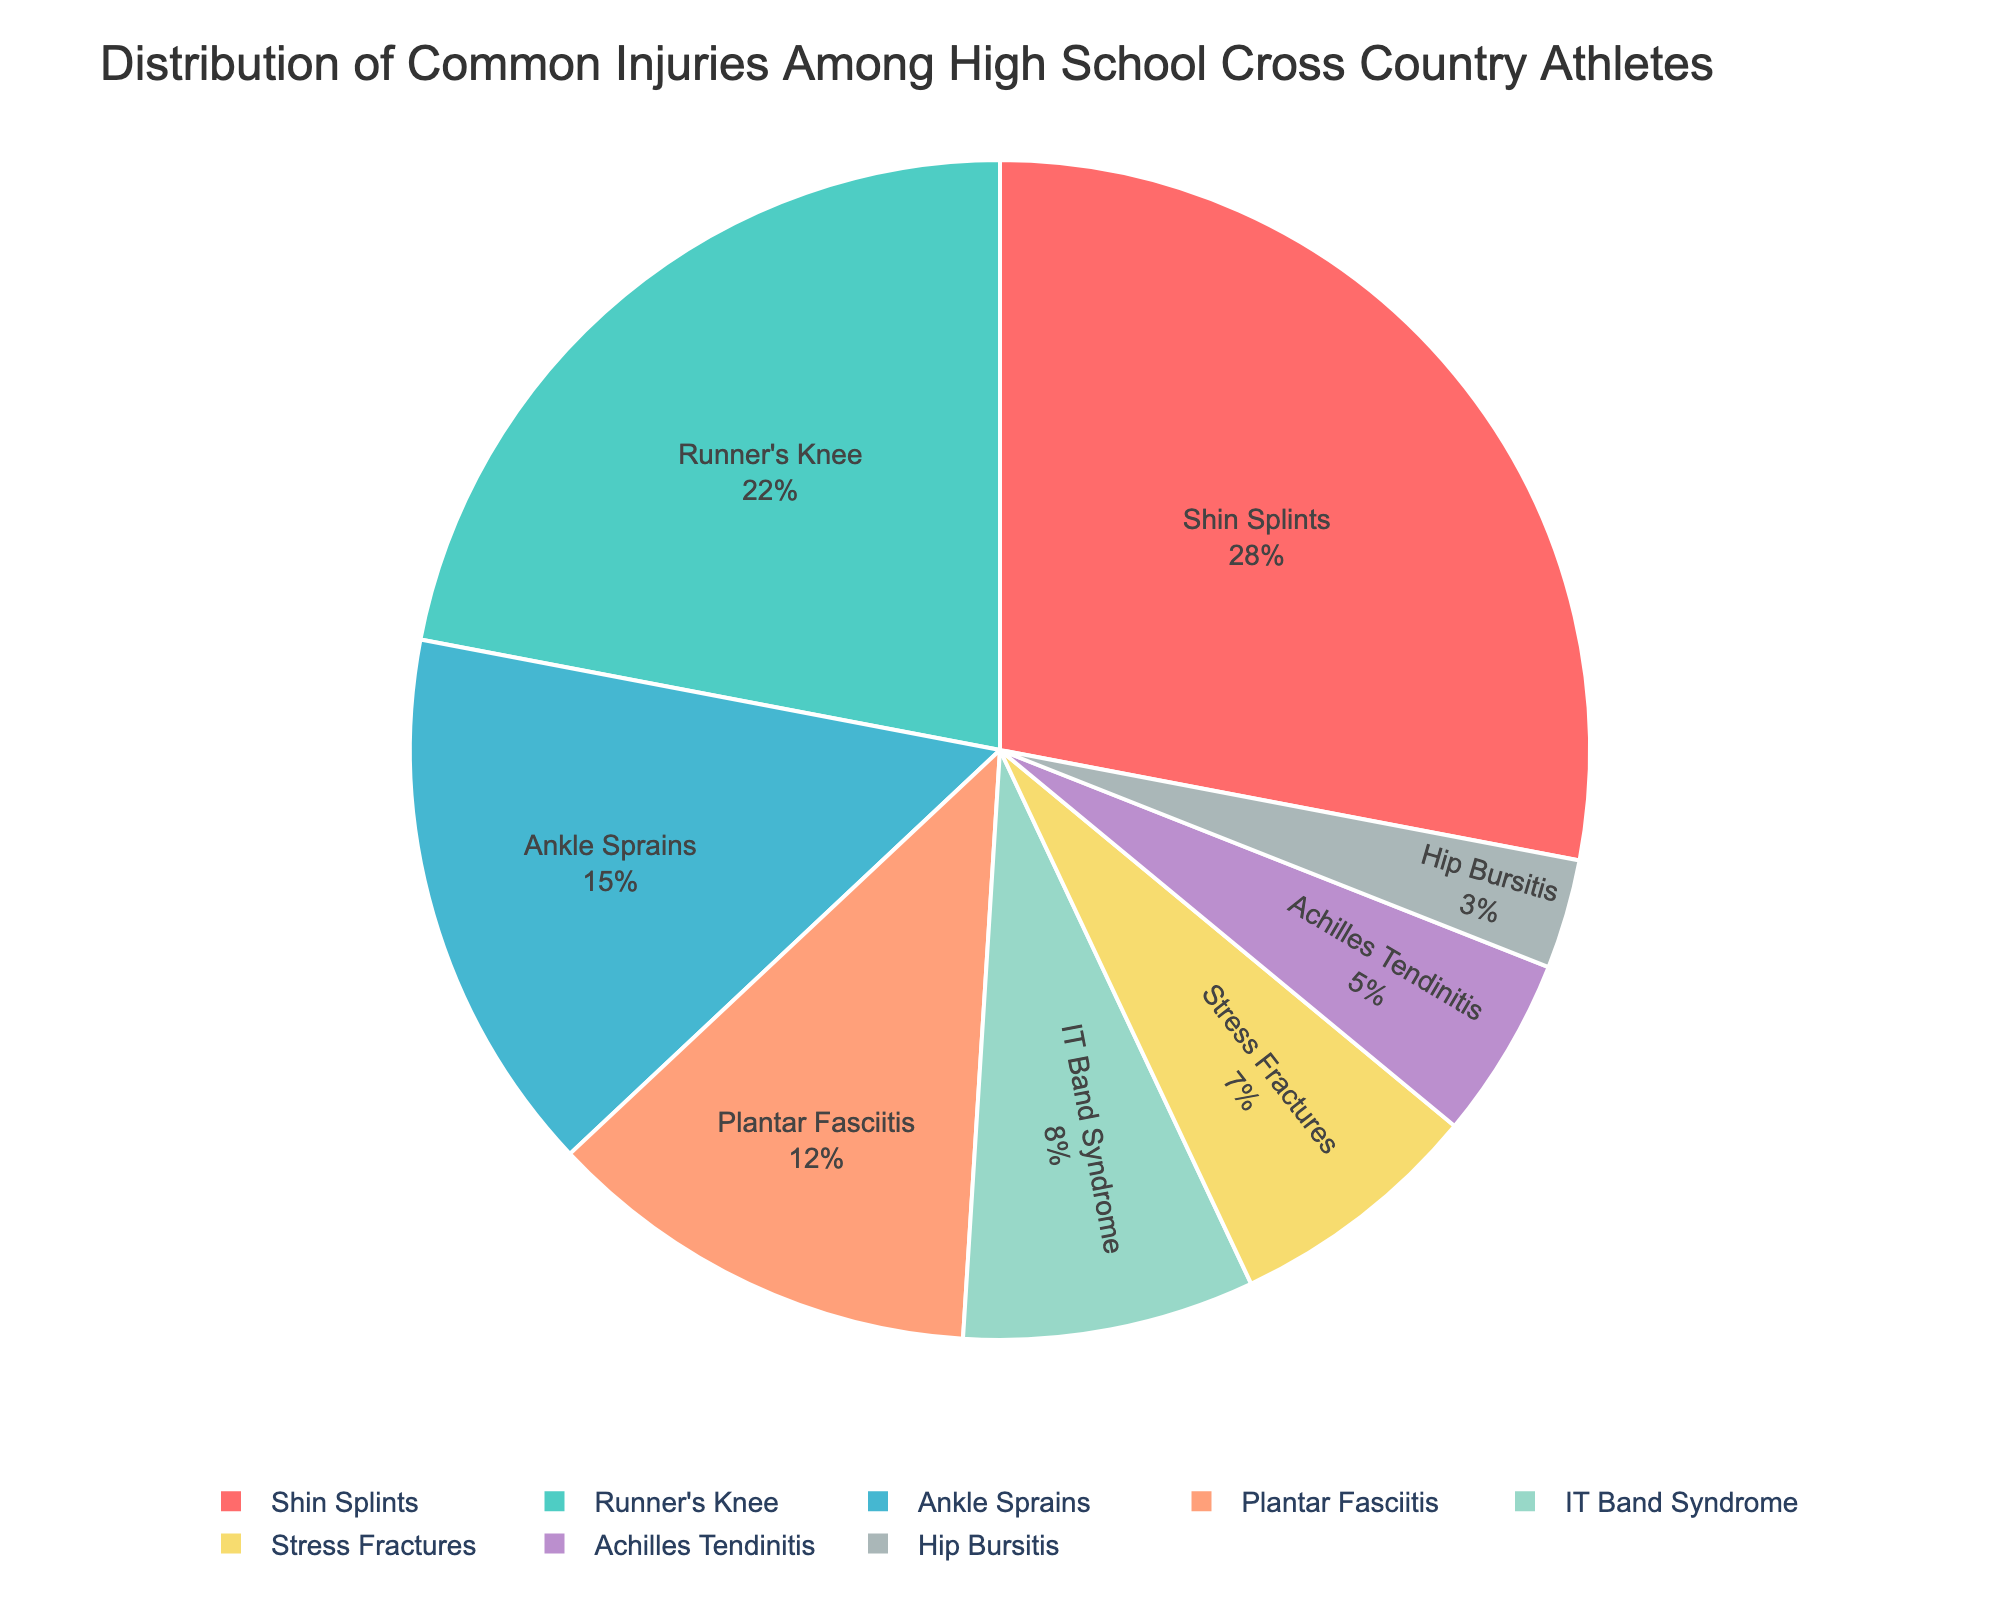Which injury type is most common among high school cross country athletes? The largest segment of the pie chart represents the injury type with the highest percentage. By looking at the chart, "Shin Splints" has the largest segment.
Answer: Shin Splints Which injury type is least common among high school cross country athletes? The smallest segment of the pie chart represents the injury type with the lowest percentage. By observing the chart, "Hip Bursitis" has the smallest segment.
Answer: Hip Bursitis What is the combined percentage of shin splints and runner's knee? Combine the percentages of "Shin Splints" and "Runner's Knee" by adding their values: 28% + 22% = 50%.
Answer: 50% How much larger is the percentage of shin splints compared to ankle sprains? Subtract the percentage of "Ankle Sprains" from the percentage of "Shin Splints": 28% - 15% = 13%.
Answer: 13% What percentage of injuries are accounted for by stress fractures and Achilles tendinitis combined? Add the percentages of "Stress Fractures" and "Achilles Tendinitis": 7% + 5% = 12%.
Answer: 12% Which two injury types together make up more than a third of all injuries? Find two segments whose combined percentage exceeds 33%. "Shin Splints" and "Runner's Knee" together make up 28% + 22% = 50%, which is more than one-third.
Answer: Shin Splints and Runner's Knee What is the visual attribute used to distinguish different injury types in the pie chart? The pie chart uses different colors to represent each injury type.
Answer: Different colors How many injury types have a percentage greater than or equal to 12%? Count all the segments in the pie chart with a percentage of 12% or higher: Shin Splints (28%), Runner's Knee (22%), Ankle Sprains (15%), and Plantar Fasciitis (12%). There are four such injury types.
Answer: 4 Which injury type is represented by the color that comes first in a rainbow sequence? By examining the pie chart colors, "Shin Splints" is represented by red, which comes first in a rainbow sequence (red, orange, yellow, green, etc.).
Answer: Shin Splints 